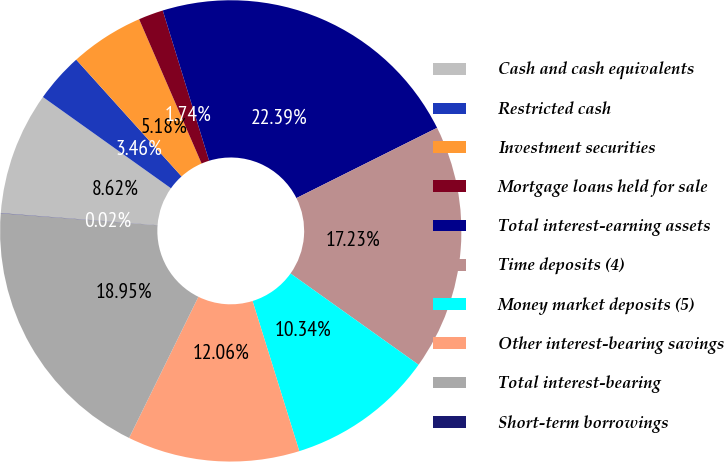Convert chart. <chart><loc_0><loc_0><loc_500><loc_500><pie_chart><fcel>Cash and cash equivalents<fcel>Restricted cash<fcel>Investment securities<fcel>Mortgage loans held for sale<fcel>Total interest-earning assets<fcel>Time deposits (4)<fcel>Money market deposits (5)<fcel>Other interest-bearing savings<fcel>Total interest-bearing<fcel>Short-term borrowings<nl><fcel>8.62%<fcel>3.46%<fcel>5.18%<fcel>1.74%<fcel>22.38%<fcel>17.22%<fcel>10.34%<fcel>12.06%<fcel>18.94%<fcel>0.02%<nl></chart> 